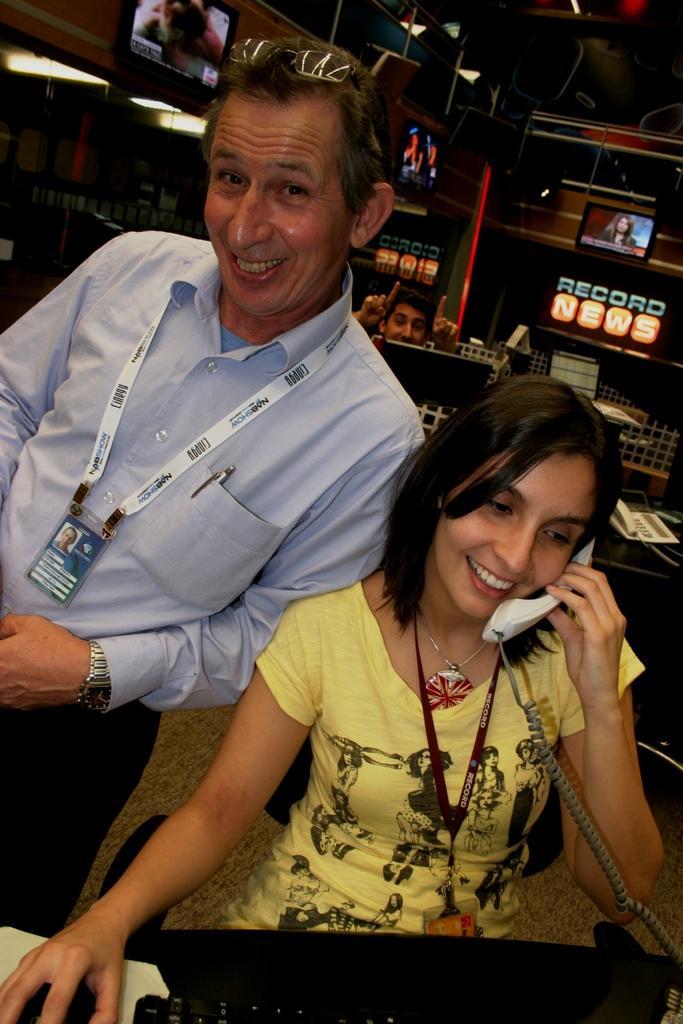Describe this image in one or two sentences. At the bottom of the image there is a table, on the table there is a keyboard and mouse. Behind the table a woman is sitting and holding a landline phone and smiling. Behind her a man is standing and smiling. Behind them a person is sitting and watching. At the top of the image there is wall, on the wall there are some screens. 